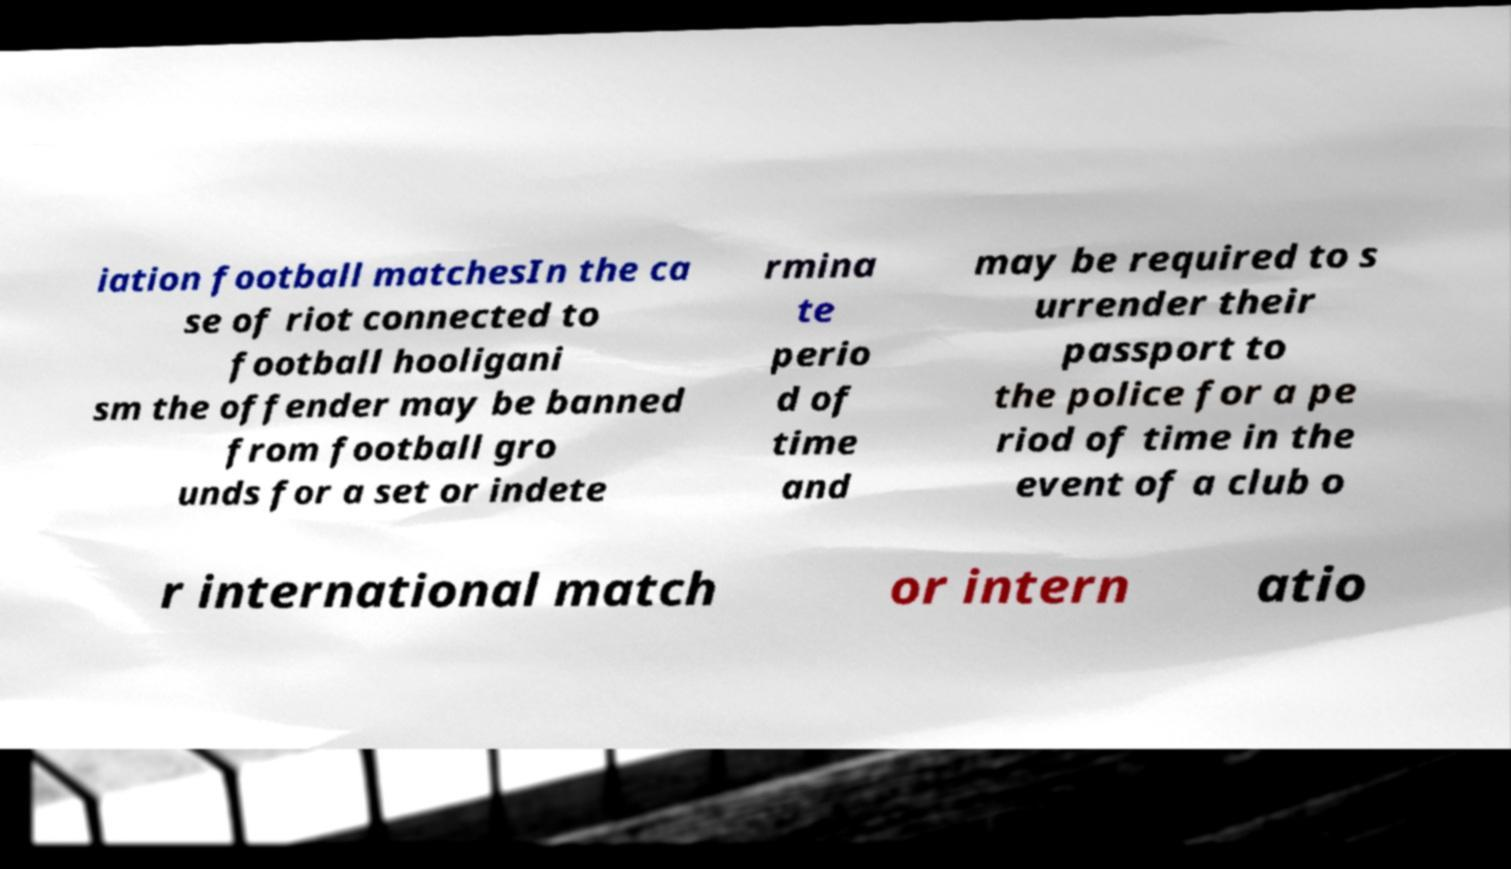Can you read and provide the text displayed in the image?This photo seems to have some interesting text. Can you extract and type it out for me? iation football matchesIn the ca se of riot connected to football hooligani sm the offender may be banned from football gro unds for a set or indete rmina te perio d of time and may be required to s urrender their passport to the police for a pe riod of time in the event of a club o r international match or intern atio 